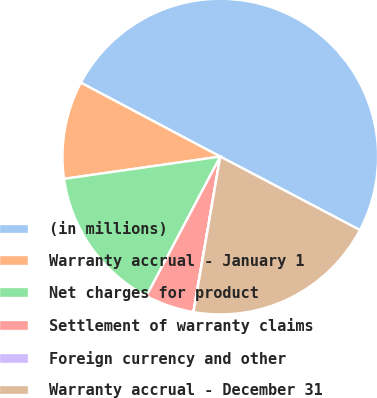<chart> <loc_0><loc_0><loc_500><loc_500><pie_chart><fcel>(in millions)<fcel>Warranty accrual - January 1<fcel>Net charges for product<fcel>Settlement of warranty claims<fcel>Foreign currency and other<fcel>Warranty accrual - December 31<nl><fcel>49.95%<fcel>10.01%<fcel>15.0%<fcel>5.02%<fcel>0.02%<fcel>20.0%<nl></chart> 